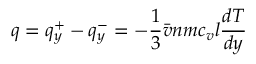Convert formula to latex. <formula><loc_0><loc_0><loc_500><loc_500>q = q _ { y } ^ { + } - q _ { y } ^ { - } = - { \frac { 1 } { 3 } } { \bar { v } } n m c _ { v } l { \frac { d T } { d y } }</formula> 